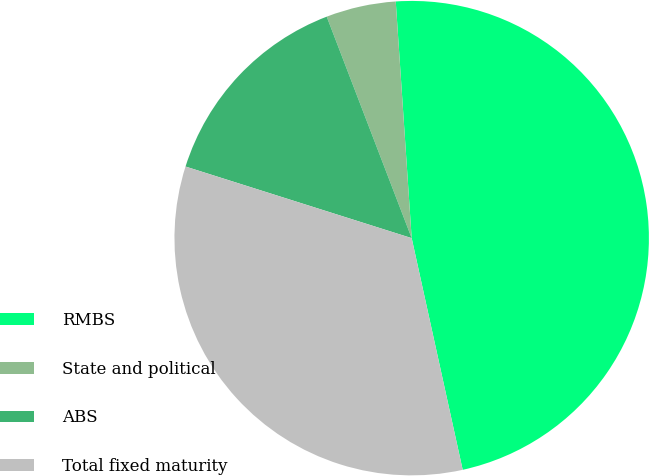<chart> <loc_0><loc_0><loc_500><loc_500><pie_chart><fcel>RMBS<fcel>State and political<fcel>ABS<fcel>Total fixed maturity<nl><fcel>47.62%<fcel>4.76%<fcel>14.29%<fcel>33.33%<nl></chart> 